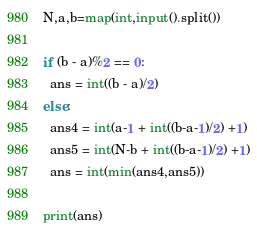Convert code to text. <code><loc_0><loc_0><loc_500><loc_500><_Python_>N,a,b=map(int,input().split())

if (b - a)%2 == 0:
  ans = int((b - a)/2)
else:
  ans4 = int(a-1 + int((b-a-1)/2) +1)
  ans5 = int(N-b + int((b-a-1)/2) +1)
  ans = int(min(ans4,ans5))
  
print(ans)
</code> 